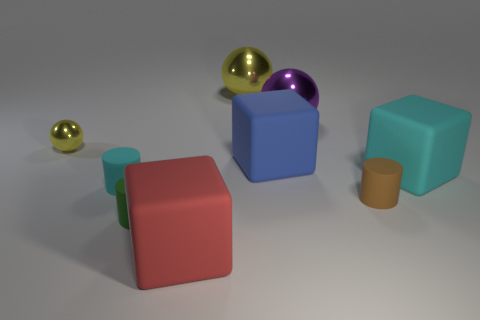There is a cyan object that is the same size as the brown rubber cylinder; what material is it?
Your answer should be very brief. Rubber. What number of other objects are the same material as the large yellow object?
Provide a short and direct response. 2. There is a purple metallic sphere; does it have the same size as the matte block behind the big cyan rubber object?
Provide a succinct answer. Yes. Are there fewer tiny cylinders left of the green matte object than big blocks behind the brown thing?
Offer a very short reply. Yes. What size is the brown cylinder that is on the right side of the purple ball?
Give a very brief answer. Small. Do the blue rubber cube and the red thing have the same size?
Offer a terse response. Yes. How many matte objects are to the right of the green matte cylinder and in front of the brown cylinder?
Make the answer very short. 1. How many blue objects are large shiny things or matte objects?
Keep it short and to the point. 1. What number of metal things are either tiny cyan blocks or big yellow objects?
Make the answer very short. 1. Are any green rubber objects visible?
Make the answer very short. Yes. 